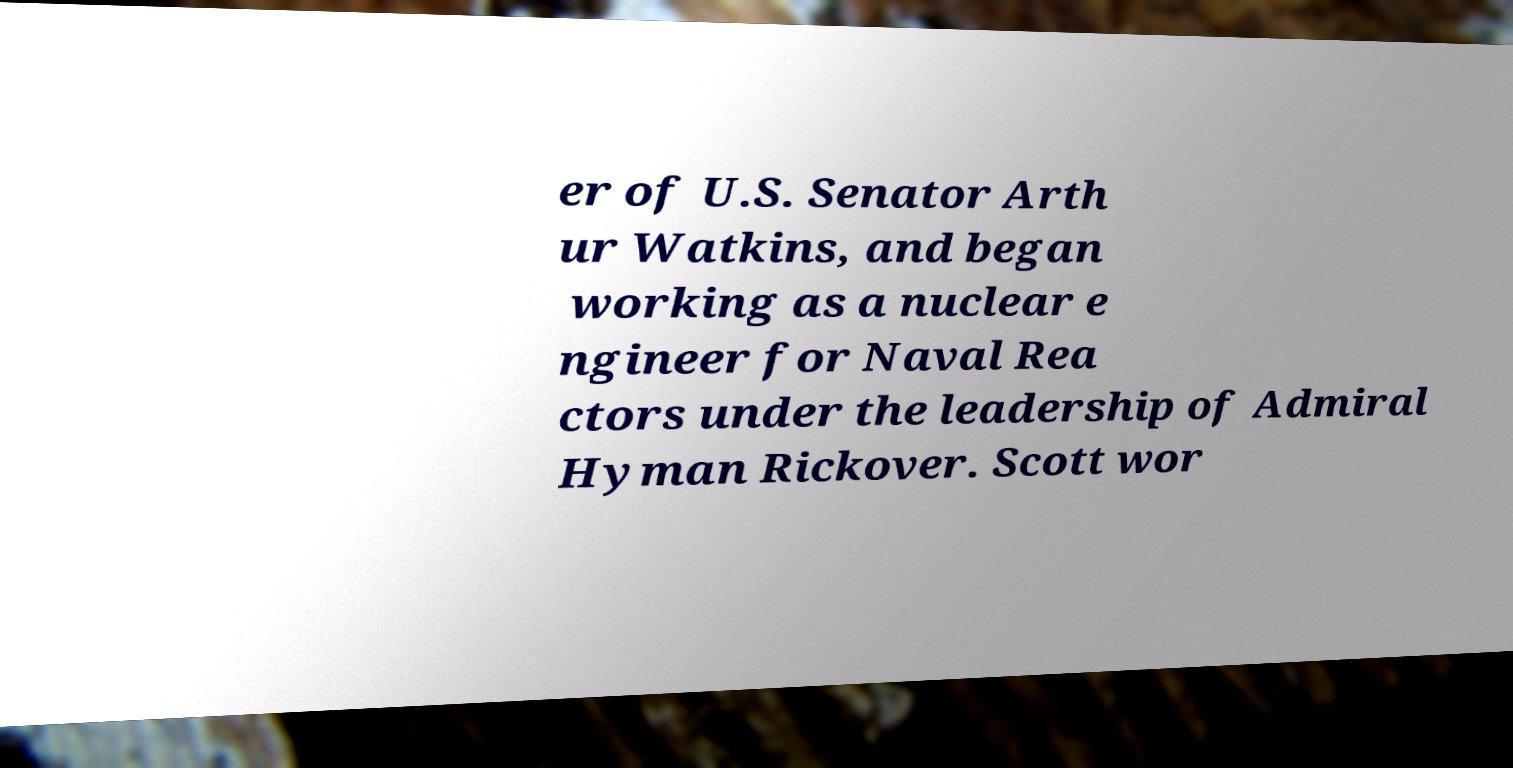There's text embedded in this image that I need extracted. Can you transcribe it verbatim? er of U.S. Senator Arth ur Watkins, and began working as a nuclear e ngineer for Naval Rea ctors under the leadership of Admiral Hyman Rickover. Scott wor 